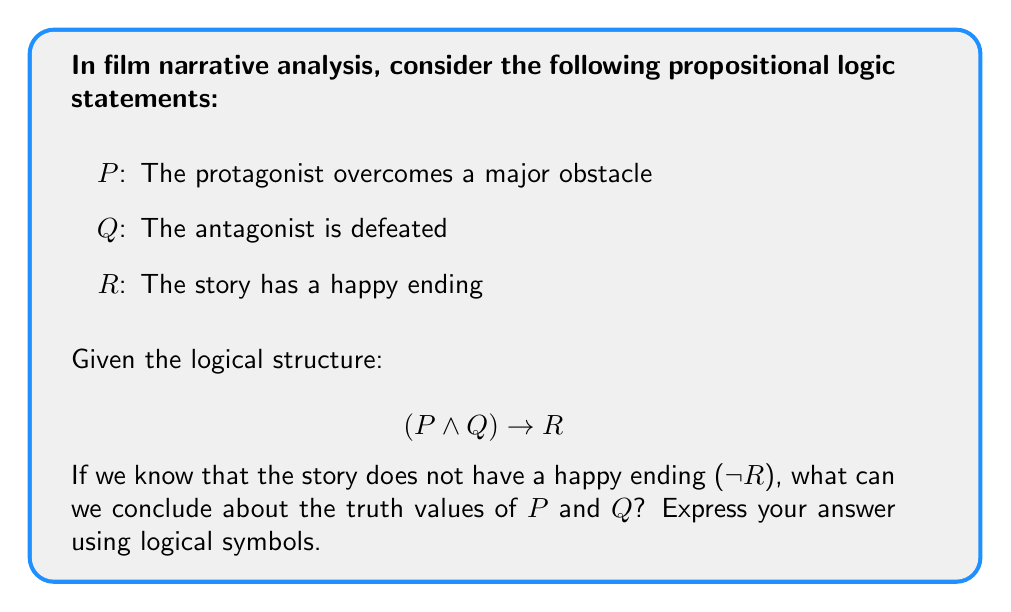Could you help me with this problem? Let's approach this step-by-step using propositional logic:

1. We are given the logical structure: $$(P \wedge Q) \rightarrow R$$

2. We know that the story does not have a happy ending, which means $\neg R$ is true.

3. In propositional logic, if we have $A \rightarrow B$ and we know that $B$ is false, we can conclude that $A$ must also be false. This is known as modus tollens.

4. Applying modus tollens to our situation:
   $$(P \wedge Q) \rightarrow R$$
   $$\neg R$$
   $$\therefore \neg(P \wedge Q)$$

5. Now we need to apply De Morgan's law to $\neg(P \wedge Q)$:
   $$\neg(P \wedge Q) \equiv \neg P \vee \neg Q$$

6. This means that either the protagonist does not overcome a major obstacle ($\neg P$), or the antagonist is not defeated ($\neg Q$), or both.

7. In film analysis terms, this logical structure suggests that if a story doesn't have a happy ending, then either the protagonist didn't overcome their main challenge, or the antagonist wasn't defeated, or both of these conditions are true.
Answer: $\neg P \vee \neg Q$ 